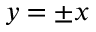<formula> <loc_0><loc_0><loc_500><loc_500>y = \pm x</formula> 